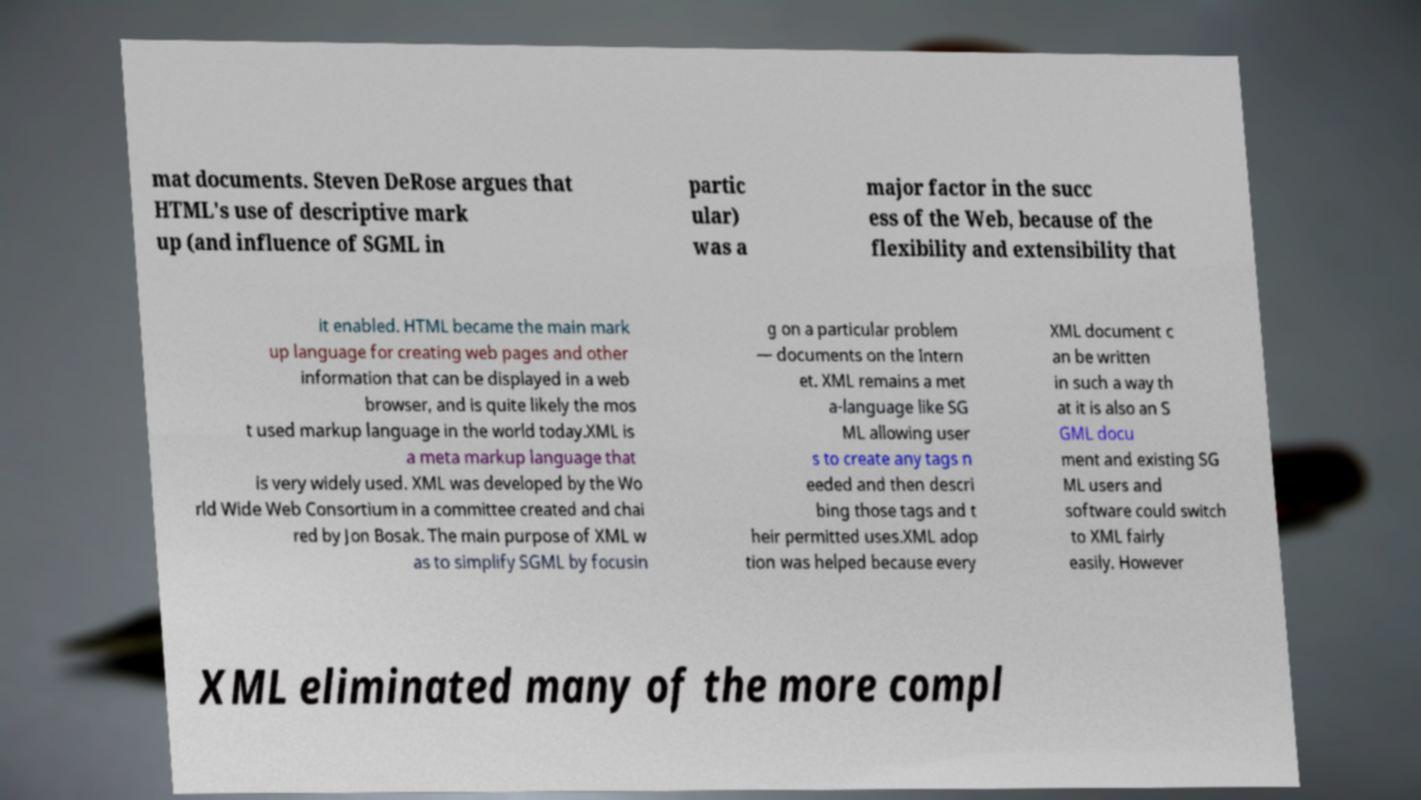Please identify and transcribe the text found in this image. mat documents. Steven DeRose argues that HTML's use of descriptive mark up (and influence of SGML in partic ular) was a major factor in the succ ess of the Web, because of the flexibility and extensibility that it enabled. HTML became the main mark up language for creating web pages and other information that can be displayed in a web browser, and is quite likely the mos t used markup language in the world today.XML is a meta markup language that is very widely used. XML was developed by the Wo rld Wide Web Consortium in a committee created and chai red by Jon Bosak. The main purpose of XML w as to simplify SGML by focusin g on a particular problem — documents on the Intern et. XML remains a met a-language like SG ML allowing user s to create any tags n eeded and then descri bing those tags and t heir permitted uses.XML adop tion was helped because every XML document c an be written in such a way th at it is also an S GML docu ment and existing SG ML users and software could switch to XML fairly easily. However XML eliminated many of the more compl 